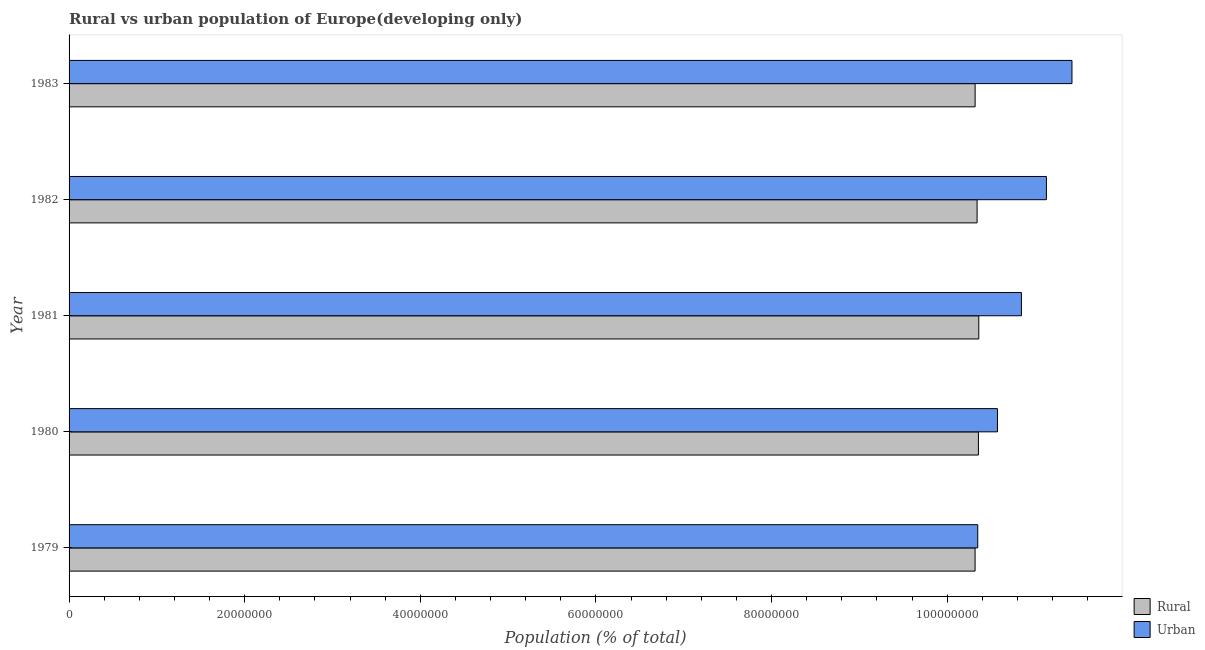How many bars are there on the 3rd tick from the top?
Your answer should be compact. 2. What is the label of the 2nd group of bars from the top?
Give a very brief answer. 1982. In how many cases, is the number of bars for a given year not equal to the number of legend labels?
Your answer should be compact. 0. What is the urban population density in 1983?
Keep it short and to the point. 1.14e+08. Across all years, what is the maximum rural population density?
Offer a terse response. 1.04e+08. Across all years, what is the minimum rural population density?
Make the answer very short. 1.03e+08. In which year was the rural population density maximum?
Provide a succinct answer. 1981. In which year was the rural population density minimum?
Give a very brief answer. 1979. What is the total urban population density in the graph?
Ensure brevity in your answer.  5.43e+08. What is the difference between the urban population density in 1981 and that in 1983?
Your response must be concise. -5.76e+06. What is the difference between the urban population density in 1983 and the rural population density in 1982?
Your answer should be very brief. 1.08e+07. What is the average urban population density per year?
Your answer should be compact. 1.09e+08. In the year 1983, what is the difference between the urban population density and rural population density?
Offer a terse response. 1.10e+07. In how many years, is the rural population density greater than 36000000 %?
Your answer should be compact. 5. What is the ratio of the urban population density in 1981 to that in 1983?
Keep it short and to the point. 0.95. Is the urban population density in 1980 less than that in 1982?
Offer a very short reply. Yes. Is the difference between the urban population density in 1979 and 1980 greater than the difference between the rural population density in 1979 and 1980?
Ensure brevity in your answer.  No. What is the difference between the highest and the second highest rural population density?
Offer a terse response. 4.00e+04. What is the difference between the highest and the lowest urban population density?
Your response must be concise. 1.07e+07. In how many years, is the rural population density greater than the average rural population density taken over all years?
Give a very brief answer. 3. What does the 2nd bar from the top in 1983 represents?
Your response must be concise. Rural. What does the 1st bar from the bottom in 1980 represents?
Offer a very short reply. Rural. Are the values on the major ticks of X-axis written in scientific E-notation?
Provide a short and direct response. No. Does the graph contain any zero values?
Your response must be concise. No. Does the graph contain grids?
Your answer should be very brief. No. What is the title of the graph?
Your answer should be compact. Rural vs urban population of Europe(developing only). What is the label or title of the X-axis?
Provide a short and direct response. Population (% of total). What is the label or title of the Y-axis?
Your answer should be compact. Year. What is the Population (% of total) of Rural in 1979?
Make the answer very short. 1.03e+08. What is the Population (% of total) of Urban in 1979?
Your response must be concise. 1.03e+08. What is the Population (% of total) of Rural in 1980?
Give a very brief answer. 1.04e+08. What is the Population (% of total) of Urban in 1980?
Make the answer very short. 1.06e+08. What is the Population (% of total) in Rural in 1981?
Your response must be concise. 1.04e+08. What is the Population (% of total) of Urban in 1981?
Provide a succinct answer. 1.08e+08. What is the Population (% of total) of Rural in 1982?
Your answer should be compact. 1.03e+08. What is the Population (% of total) in Urban in 1982?
Ensure brevity in your answer.  1.11e+08. What is the Population (% of total) in Rural in 1983?
Make the answer very short. 1.03e+08. What is the Population (% of total) of Urban in 1983?
Offer a very short reply. 1.14e+08. Across all years, what is the maximum Population (% of total) of Rural?
Keep it short and to the point. 1.04e+08. Across all years, what is the maximum Population (% of total) in Urban?
Offer a terse response. 1.14e+08. Across all years, what is the minimum Population (% of total) in Rural?
Make the answer very short. 1.03e+08. Across all years, what is the minimum Population (% of total) of Urban?
Provide a short and direct response. 1.03e+08. What is the total Population (% of total) in Rural in the graph?
Your answer should be compact. 5.17e+08. What is the total Population (% of total) of Urban in the graph?
Offer a terse response. 5.43e+08. What is the difference between the Population (% of total) of Rural in 1979 and that in 1980?
Make the answer very short. -3.81e+05. What is the difference between the Population (% of total) of Urban in 1979 and that in 1980?
Provide a short and direct response. -2.25e+06. What is the difference between the Population (% of total) in Rural in 1979 and that in 1981?
Offer a terse response. -4.21e+05. What is the difference between the Population (% of total) in Urban in 1979 and that in 1981?
Keep it short and to the point. -4.97e+06. What is the difference between the Population (% of total) in Rural in 1979 and that in 1982?
Keep it short and to the point. -2.29e+05. What is the difference between the Population (% of total) in Urban in 1979 and that in 1982?
Ensure brevity in your answer.  -7.82e+06. What is the difference between the Population (% of total) of Rural in 1979 and that in 1983?
Ensure brevity in your answer.  -5346. What is the difference between the Population (% of total) of Urban in 1979 and that in 1983?
Ensure brevity in your answer.  -1.07e+07. What is the difference between the Population (% of total) in Rural in 1980 and that in 1981?
Offer a very short reply. -4.00e+04. What is the difference between the Population (% of total) of Urban in 1980 and that in 1981?
Provide a succinct answer. -2.73e+06. What is the difference between the Population (% of total) of Rural in 1980 and that in 1982?
Ensure brevity in your answer.  1.52e+05. What is the difference between the Population (% of total) of Urban in 1980 and that in 1982?
Give a very brief answer. -5.58e+06. What is the difference between the Population (% of total) of Rural in 1980 and that in 1983?
Provide a short and direct response. 3.75e+05. What is the difference between the Population (% of total) of Urban in 1980 and that in 1983?
Make the answer very short. -8.48e+06. What is the difference between the Population (% of total) in Rural in 1981 and that in 1982?
Give a very brief answer. 1.92e+05. What is the difference between the Population (% of total) of Urban in 1981 and that in 1982?
Give a very brief answer. -2.85e+06. What is the difference between the Population (% of total) of Rural in 1981 and that in 1983?
Offer a very short reply. 4.15e+05. What is the difference between the Population (% of total) of Urban in 1981 and that in 1983?
Offer a terse response. -5.76e+06. What is the difference between the Population (% of total) in Rural in 1982 and that in 1983?
Your response must be concise. 2.24e+05. What is the difference between the Population (% of total) in Urban in 1982 and that in 1983?
Keep it short and to the point. -2.91e+06. What is the difference between the Population (% of total) in Rural in 1979 and the Population (% of total) in Urban in 1980?
Make the answer very short. -2.55e+06. What is the difference between the Population (% of total) in Rural in 1979 and the Population (% of total) in Urban in 1981?
Offer a very short reply. -5.28e+06. What is the difference between the Population (% of total) of Rural in 1979 and the Population (% of total) of Urban in 1982?
Make the answer very short. -8.13e+06. What is the difference between the Population (% of total) of Rural in 1979 and the Population (% of total) of Urban in 1983?
Offer a terse response. -1.10e+07. What is the difference between the Population (% of total) of Rural in 1980 and the Population (% of total) of Urban in 1981?
Your answer should be compact. -4.90e+06. What is the difference between the Population (% of total) of Rural in 1980 and the Population (% of total) of Urban in 1982?
Offer a terse response. -7.74e+06. What is the difference between the Population (% of total) in Rural in 1980 and the Population (% of total) in Urban in 1983?
Your answer should be very brief. -1.07e+07. What is the difference between the Population (% of total) in Rural in 1981 and the Population (% of total) in Urban in 1982?
Your answer should be compact. -7.70e+06. What is the difference between the Population (% of total) of Rural in 1981 and the Population (% of total) of Urban in 1983?
Your answer should be compact. -1.06e+07. What is the difference between the Population (% of total) in Rural in 1982 and the Population (% of total) in Urban in 1983?
Keep it short and to the point. -1.08e+07. What is the average Population (% of total) of Rural per year?
Give a very brief answer. 1.03e+08. What is the average Population (% of total) of Urban per year?
Your answer should be very brief. 1.09e+08. In the year 1979, what is the difference between the Population (% of total) in Rural and Population (% of total) in Urban?
Offer a terse response. -3.03e+05. In the year 1980, what is the difference between the Population (% of total) of Rural and Population (% of total) of Urban?
Make the answer very short. -2.17e+06. In the year 1981, what is the difference between the Population (% of total) in Rural and Population (% of total) in Urban?
Provide a succinct answer. -4.86e+06. In the year 1982, what is the difference between the Population (% of total) of Rural and Population (% of total) of Urban?
Your response must be concise. -7.90e+06. In the year 1983, what is the difference between the Population (% of total) in Rural and Population (% of total) in Urban?
Offer a very short reply. -1.10e+07. What is the ratio of the Population (% of total) of Urban in 1979 to that in 1980?
Offer a terse response. 0.98. What is the ratio of the Population (% of total) of Urban in 1979 to that in 1981?
Provide a succinct answer. 0.95. What is the ratio of the Population (% of total) of Rural in 1979 to that in 1982?
Your answer should be compact. 1. What is the ratio of the Population (% of total) in Urban in 1979 to that in 1982?
Provide a short and direct response. 0.93. What is the ratio of the Population (% of total) of Urban in 1979 to that in 1983?
Offer a very short reply. 0.91. What is the ratio of the Population (% of total) in Urban in 1980 to that in 1981?
Offer a terse response. 0.97. What is the ratio of the Population (% of total) of Rural in 1980 to that in 1982?
Give a very brief answer. 1. What is the ratio of the Population (% of total) in Urban in 1980 to that in 1982?
Make the answer very short. 0.95. What is the ratio of the Population (% of total) of Urban in 1980 to that in 1983?
Offer a very short reply. 0.93. What is the ratio of the Population (% of total) in Rural in 1981 to that in 1982?
Your answer should be very brief. 1. What is the ratio of the Population (% of total) in Urban in 1981 to that in 1982?
Your answer should be compact. 0.97. What is the ratio of the Population (% of total) in Rural in 1981 to that in 1983?
Your answer should be compact. 1. What is the ratio of the Population (% of total) of Urban in 1981 to that in 1983?
Ensure brevity in your answer.  0.95. What is the ratio of the Population (% of total) in Rural in 1982 to that in 1983?
Ensure brevity in your answer.  1. What is the ratio of the Population (% of total) of Urban in 1982 to that in 1983?
Offer a terse response. 0.97. What is the difference between the highest and the second highest Population (% of total) in Rural?
Provide a short and direct response. 4.00e+04. What is the difference between the highest and the second highest Population (% of total) in Urban?
Provide a short and direct response. 2.91e+06. What is the difference between the highest and the lowest Population (% of total) in Rural?
Make the answer very short. 4.21e+05. What is the difference between the highest and the lowest Population (% of total) of Urban?
Provide a short and direct response. 1.07e+07. 